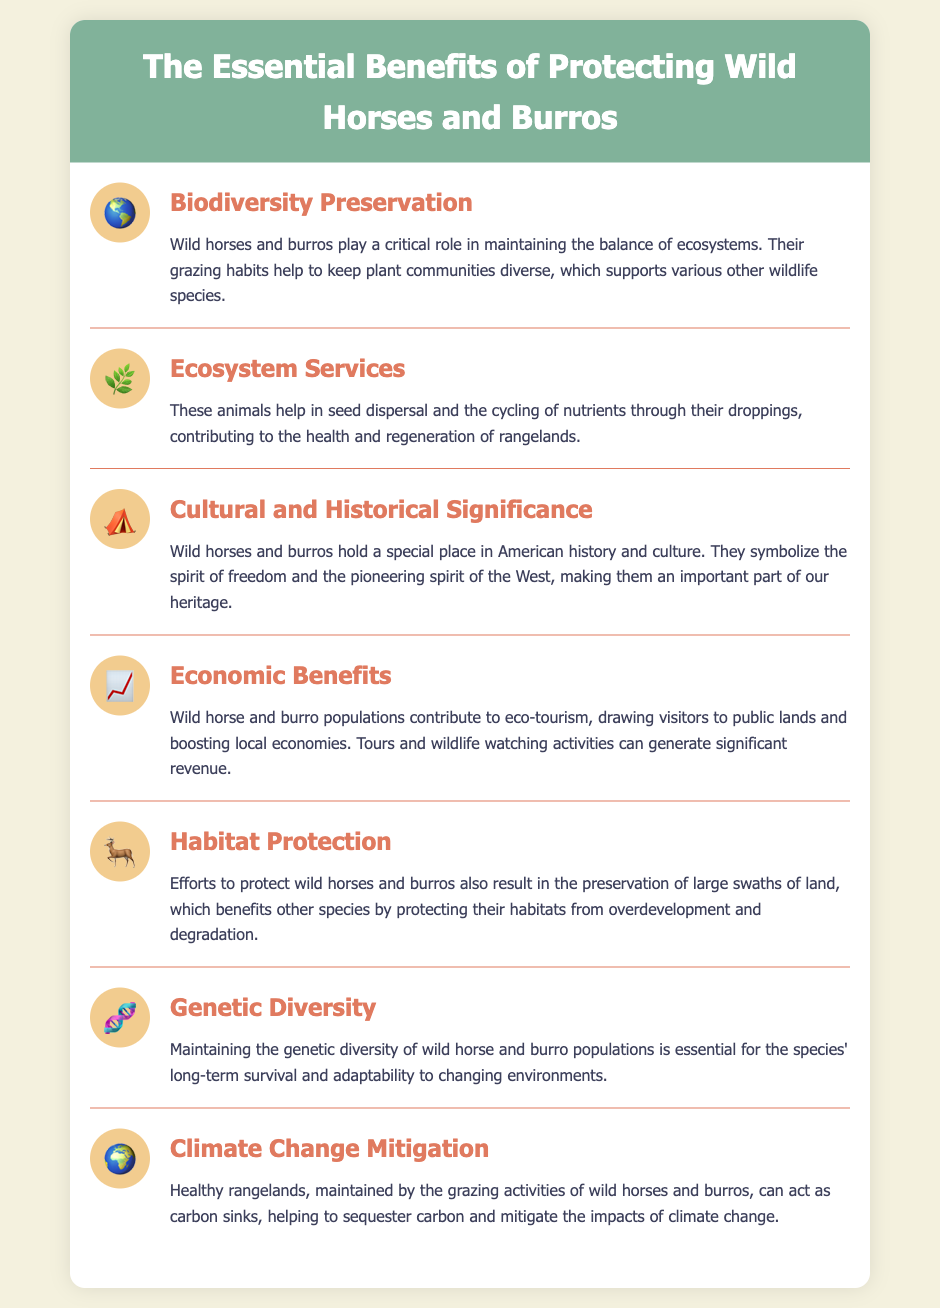What role do wild horses and burros play in ecosystems? The document states that wild horses and burros play a critical role in maintaining the balance of ecosystems through their grazing habits.
Answer: Critical role What are the economic contributions of wild horse and burro populations? The document mentions that wild horse and burro populations contribute to eco-tourism and boost local economies.
Answer: Eco-tourism What is the cultural significance of wild horses and burros? According to the document, wild horses and burros symbolize the spirit of freedom and the pioneering spirit of the West.
Answer: Spirit of freedom How do wild horses and burros contribute to climate change mitigation? The document explains that healthy rangelands maintained by these animals can act as carbon sinks to sequester carbon.
Answer: Carbon sinks What type of diversity is essential for the long-term survival of wild horse and burro populations? The document highlights that maintaining genetic diversity is essential for the species' long-term survival and adaptability.
Answer: Genetic diversity Which ecosystem service is mentioned in relation to wild horses and burros? The document states that these animals help in seed dispersal and nutrient cycling through their droppings.
Answer: Seed dispersal How do efforts to protect wild horses and burros benefit other species? The document indicates that such efforts result in the preservation of habitats from overdevelopment and degradation.
Answer: Habitat preservation What is a key ecological benefit mentioned in the document relating to grazing? The document points out that their grazing habits help keep plant communities diverse.
Answer: Plant community diversity 